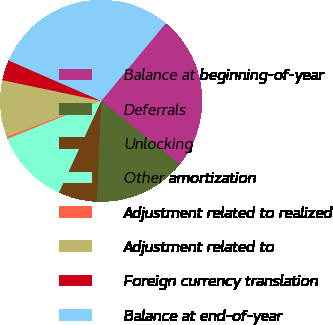<chart> <loc_0><loc_0><loc_500><loc_500><pie_chart><fcel>Balance at beginning-of-year<fcel>Deferrals<fcel>Unlocking<fcel>Other amortization<fcel>Adjustment related to realized<fcel>Adjustment related to<fcel>Foreign currency translation<fcel>Balance at end-of-year<nl><fcel>24.75%<fcel>14.91%<fcel>6.17%<fcel>12.0%<fcel>0.34%<fcel>9.08%<fcel>3.25%<fcel>29.49%<nl></chart> 